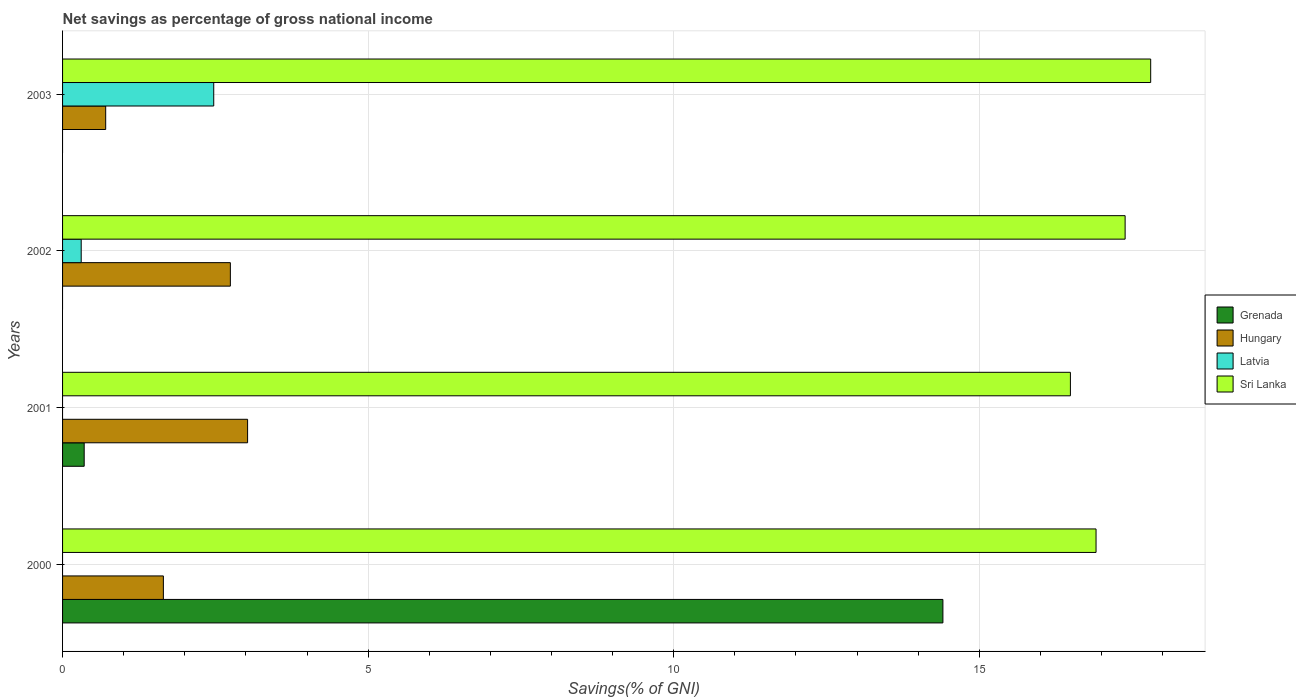How many different coloured bars are there?
Offer a very short reply. 4. How many groups of bars are there?
Offer a very short reply. 4. How many bars are there on the 1st tick from the bottom?
Your response must be concise. 3. What is the label of the 4th group of bars from the top?
Give a very brief answer. 2000. In how many cases, is the number of bars for a given year not equal to the number of legend labels?
Provide a short and direct response. 4. What is the total savings in Latvia in 2000?
Your answer should be compact. 0. Across all years, what is the maximum total savings in Sri Lanka?
Make the answer very short. 17.8. Across all years, what is the minimum total savings in Grenada?
Give a very brief answer. 0. What is the total total savings in Latvia in the graph?
Offer a very short reply. 2.78. What is the difference between the total savings in Hungary in 2001 and that in 2002?
Give a very brief answer. 0.28. What is the difference between the total savings in Grenada in 2001 and the total savings in Latvia in 2003?
Your answer should be compact. -2.12. What is the average total savings in Hungary per year?
Offer a terse response. 2.03. In the year 2003, what is the difference between the total savings in Sri Lanka and total savings in Hungary?
Offer a very short reply. 17.1. In how many years, is the total savings in Grenada greater than 2 %?
Give a very brief answer. 1. What is the ratio of the total savings in Hungary in 2001 to that in 2003?
Offer a terse response. 4.29. Is the total savings in Sri Lanka in 2001 less than that in 2003?
Offer a terse response. Yes. What is the difference between the highest and the second highest total savings in Hungary?
Keep it short and to the point. 0.28. What is the difference between the highest and the lowest total savings in Grenada?
Your answer should be compact. 14.4. Is it the case that in every year, the sum of the total savings in Sri Lanka and total savings in Hungary is greater than the sum of total savings in Latvia and total savings in Grenada?
Your response must be concise. Yes. Is it the case that in every year, the sum of the total savings in Latvia and total savings in Sri Lanka is greater than the total savings in Hungary?
Your response must be concise. Yes. How many bars are there?
Ensure brevity in your answer.  12. Are all the bars in the graph horizontal?
Offer a terse response. Yes. Are the values on the major ticks of X-axis written in scientific E-notation?
Your answer should be compact. No. Does the graph contain any zero values?
Your answer should be compact. Yes. Does the graph contain grids?
Your response must be concise. Yes. How are the legend labels stacked?
Your answer should be compact. Vertical. What is the title of the graph?
Keep it short and to the point. Net savings as percentage of gross national income. Does "Albania" appear as one of the legend labels in the graph?
Your answer should be compact. No. What is the label or title of the X-axis?
Offer a terse response. Savings(% of GNI). What is the label or title of the Y-axis?
Your response must be concise. Years. What is the Savings(% of GNI) of Grenada in 2000?
Keep it short and to the point. 14.4. What is the Savings(% of GNI) in Hungary in 2000?
Provide a short and direct response. 1.65. What is the Savings(% of GNI) of Latvia in 2000?
Keep it short and to the point. 0. What is the Savings(% of GNI) in Sri Lanka in 2000?
Ensure brevity in your answer.  16.91. What is the Savings(% of GNI) in Grenada in 2001?
Offer a very short reply. 0.35. What is the Savings(% of GNI) in Hungary in 2001?
Ensure brevity in your answer.  3.03. What is the Savings(% of GNI) of Latvia in 2001?
Your response must be concise. 0. What is the Savings(% of GNI) of Sri Lanka in 2001?
Provide a succinct answer. 16.49. What is the Savings(% of GNI) of Grenada in 2002?
Keep it short and to the point. 0. What is the Savings(% of GNI) of Hungary in 2002?
Give a very brief answer. 2.75. What is the Savings(% of GNI) in Latvia in 2002?
Your answer should be compact. 0.3. What is the Savings(% of GNI) of Sri Lanka in 2002?
Ensure brevity in your answer.  17.39. What is the Savings(% of GNI) of Grenada in 2003?
Your response must be concise. 0. What is the Savings(% of GNI) of Hungary in 2003?
Give a very brief answer. 0.71. What is the Savings(% of GNI) in Latvia in 2003?
Offer a terse response. 2.47. What is the Savings(% of GNI) in Sri Lanka in 2003?
Offer a very short reply. 17.8. Across all years, what is the maximum Savings(% of GNI) of Grenada?
Your response must be concise. 14.4. Across all years, what is the maximum Savings(% of GNI) of Hungary?
Ensure brevity in your answer.  3.03. Across all years, what is the maximum Savings(% of GNI) of Latvia?
Ensure brevity in your answer.  2.47. Across all years, what is the maximum Savings(% of GNI) in Sri Lanka?
Your answer should be compact. 17.8. Across all years, what is the minimum Savings(% of GNI) in Hungary?
Offer a very short reply. 0.71. Across all years, what is the minimum Savings(% of GNI) in Sri Lanka?
Provide a succinct answer. 16.49. What is the total Savings(% of GNI) of Grenada in the graph?
Ensure brevity in your answer.  14.76. What is the total Savings(% of GNI) in Hungary in the graph?
Make the answer very short. 8.13. What is the total Savings(% of GNI) in Latvia in the graph?
Your response must be concise. 2.78. What is the total Savings(% of GNI) in Sri Lanka in the graph?
Make the answer very short. 68.59. What is the difference between the Savings(% of GNI) in Grenada in 2000 and that in 2001?
Make the answer very short. 14.05. What is the difference between the Savings(% of GNI) of Hungary in 2000 and that in 2001?
Ensure brevity in your answer.  -1.38. What is the difference between the Savings(% of GNI) in Sri Lanka in 2000 and that in 2001?
Keep it short and to the point. 0.42. What is the difference between the Savings(% of GNI) of Hungary in 2000 and that in 2002?
Ensure brevity in your answer.  -1.1. What is the difference between the Savings(% of GNI) of Sri Lanka in 2000 and that in 2002?
Ensure brevity in your answer.  -0.48. What is the difference between the Savings(% of GNI) in Hungary in 2000 and that in 2003?
Give a very brief answer. 0.94. What is the difference between the Savings(% of GNI) of Sri Lanka in 2000 and that in 2003?
Provide a short and direct response. -0.89. What is the difference between the Savings(% of GNI) of Hungary in 2001 and that in 2002?
Your answer should be very brief. 0.28. What is the difference between the Savings(% of GNI) in Sri Lanka in 2001 and that in 2002?
Offer a terse response. -0.9. What is the difference between the Savings(% of GNI) of Hungary in 2001 and that in 2003?
Provide a succinct answer. 2.32. What is the difference between the Savings(% of GNI) in Sri Lanka in 2001 and that in 2003?
Your answer should be very brief. -1.31. What is the difference between the Savings(% of GNI) in Hungary in 2002 and that in 2003?
Your answer should be compact. 2.04. What is the difference between the Savings(% of GNI) of Latvia in 2002 and that in 2003?
Give a very brief answer. -2.17. What is the difference between the Savings(% of GNI) in Sri Lanka in 2002 and that in 2003?
Your answer should be compact. -0.42. What is the difference between the Savings(% of GNI) of Grenada in 2000 and the Savings(% of GNI) of Hungary in 2001?
Your response must be concise. 11.38. What is the difference between the Savings(% of GNI) in Grenada in 2000 and the Savings(% of GNI) in Sri Lanka in 2001?
Ensure brevity in your answer.  -2.09. What is the difference between the Savings(% of GNI) of Hungary in 2000 and the Savings(% of GNI) of Sri Lanka in 2001?
Ensure brevity in your answer.  -14.84. What is the difference between the Savings(% of GNI) in Grenada in 2000 and the Savings(% of GNI) in Hungary in 2002?
Offer a very short reply. 11.66. What is the difference between the Savings(% of GNI) of Grenada in 2000 and the Savings(% of GNI) of Latvia in 2002?
Give a very brief answer. 14.1. What is the difference between the Savings(% of GNI) of Grenada in 2000 and the Savings(% of GNI) of Sri Lanka in 2002?
Give a very brief answer. -2.98. What is the difference between the Savings(% of GNI) in Hungary in 2000 and the Savings(% of GNI) in Latvia in 2002?
Your answer should be very brief. 1.34. What is the difference between the Savings(% of GNI) of Hungary in 2000 and the Savings(% of GNI) of Sri Lanka in 2002?
Keep it short and to the point. -15.74. What is the difference between the Savings(% of GNI) of Grenada in 2000 and the Savings(% of GNI) of Hungary in 2003?
Your response must be concise. 13.7. What is the difference between the Savings(% of GNI) in Grenada in 2000 and the Savings(% of GNI) in Latvia in 2003?
Your response must be concise. 11.93. What is the difference between the Savings(% of GNI) of Grenada in 2000 and the Savings(% of GNI) of Sri Lanka in 2003?
Offer a terse response. -3.4. What is the difference between the Savings(% of GNI) in Hungary in 2000 and the Savings(% of GNI) in Latvia in 2003?
Give a very brief answer. -0.82. What is the difference between the Savings(% of GNI) in Hungary in 2000 and the Savings(% of GNI) in Sri Lanka in 2003?
Give a very brief answer. -16.16. What is the difference between the Savings(% of GNI) of Grenada in 2001 and the Savings(% of GNI) of Hungary in 2002?
Ensure brevity in your answer.  -2.39. What is the difference between the Savings(% of GNI) in Grenada in 2001 and the Savings(% of GNI) in Latvia in 2002?
Keep it short and to the point. 0.05. What is the difference between the Savings(% of GNI) of Grenada in 2001 and the Savings(% of GNI) of Sri Lanka in 2002?
Keep it short and to the point. -17.03. What is the difference between the Savings(% of GNI) of Hungary in 2001 and the Savings(% of GNI) of Latvia in 2002?
Provide a succinct answer. 2.72. What is the difference between the Savings(% of GNI) of Hungary in 2001 and the Savings(% of GNI) of Sri Lanka in 2002?
Your response must be concise. -14.36. What is the difference between the Savings(% of GNI) of Grenada in 2001 and the Savings(% of GNI) of Hungary in 2003?
Offer a very short reply. -0.35. What is the difference between the Savings(% of GNI) in Grenada in 2001 and the Savings(% of GNI) in Latvia in 2003?
Provide a short and direct response. -2.12. What is the difference between the Savings(% of GNI) of Grenada in 2001 and the Savings(% of GNI) of Sri Lanka in 2003?
Your answer should be very brief. -17.45. What is the difference between the Savings(% of GNI) of Hungary in 2001 and the Savings(% of GNI) of Latvia in 2003?
Offer a very short reply. 0.55. What is the difference between the Savings(% of GNI) of Hungary in 2001 and the Savings(% of GNI) of Sri Lanka in 2003?
Give a very brief answer. -14.78. What is the difference between the Savings(% of GNI) in Hungary in 2002 and the Savings(% of GNI) in Latvia in 2003?
Give a very brief answer. 0.27. What is the difference between the Savings(% of GNI) of Hungary in 2002 and the Savings(% of GNI) of Sri Lanka in 2003?
Your response must be concise. -15.06. What is the difference between the Savings(% of GNI) in Latvia in 2002 and the Savings(% of GNI) in Sri Lanka in 2003?
Offer a terse response. -17.5. What is the average Savings(% of GNI) of Grenada per year?
Offer a terse response. 3.69. What is the average Savings(% of GNI) of Hungary per year?
Make the answer very short. 2.03. What is the average Savings(% of GNI) in Latvia per year?
Your answer should be compact. 0.69. What is the average Savings(% of GNI) in Sri Lanka per year?
Your answer should be compact. 17.15. In the year 2000, what is the difference between the Savings(% of GNI) of Grenada and Savings(% of GNI) of Hungary?
Give a very brief answer. 12.76. In the year 2000, what is the difference between the Savings(% of GNI) of Grenada and Savings(% of GNI) of Sri Lanka?
Offer a terse response. -2.51. In the year 2000, what is the difference between the Savings(% of GNI) of Hungary and Savings(% of GNI) of Sri Lanka?
Provide a short and direct response. -15.26. In the year 2001, what is the difference between the Savings(% of GNI) of Grenada and Savings(% of GNI) of Hungary?
Provide a short and direct response. -2.67. In the year 2001, what is the difference between the Savings(% of GNI) of Grenada and Savings(% of GNI) of Sri Lanka?
Your answer should be compact. -16.14. In the year 2001, what is the difference between the Savings(% of GNI) in Hungary and Savings(% of GNI) in Sri Lanka?
Your answer should be compact. -13.46. In the year 2002, what is the difference between the Savings(% of GNI) of Hungary and Savings(% of GNI) of Latvia?
Keep it short and to the point. 2.44. In the year 2002, what is the difference between the Savings(% of GNI) of Hungary and Savings(% of GNI) of Sri Lanka?
Your answer should be compact. -14.64. In the year 2002, what is the difference between the Savings(% of GNI) in Latvia and Savings(% of GNI) in Sri Lanka?
Your response must be concise. -17.08. In the year 2003, what is the difference between the Savings(% of GNI) in Hungary and Savings(% of GNI) in Latvia?
Provide a short and direct response. -1.77. In the year 2003, what is the difference between the Savings(% of GNI) of Hungary and Savings(% of GNI) of Sri Lanka?
Offer a terse response. -17.1. In the year 2003, what is the difference between the Savings(% of GNI) in Latvia and Savings(% of GNI) in Sri Lanka?
Provide a succinct answer. -15.33. What is the ratio of the Savings(% of GNI) in Grenada in 2000 to that in 2001?
Your answer should be compact. 40.71. What is the ratio of the Savings(% of GNI) in Hungary in 2000 to that in 2001?
Ensure brevity in your answer.  0.54. What is the ratio of the Savings(% of GNI) of Sri Lanka in 2000 to that in 2001?
Ensure brevity in your answer.  1.03. What is the ratio of the Savings(% of GNI) in Hungary in 2000 to that in 2002?
Provide a succinct answer. 0.6. What is the ratio of the Savings(% of GNI) of Sri Lanka in 2000 to that in 2002?
Your answer should be compact. 0.97. What is the ratio of the Savings(% of GNI) in Hungary in 2000 to that in 2003?
Give a very brief answer. 2.34. What is the ratio of the Savings(% of GNI) of Sri Lanka in 2000 to that in 2003?
Your answer should be compact. 0.95. What is the ratio of the Savings(% of GNI) of Hungary in 2001 to that in 2002?
Your response must be concise. 1.1. What is the ratio of the Savings(% of GNI) of Sri Lanka in 2001 to that in 2002?
Provide a short and direct response. 0.95. What is the ratio of the Savings(% of GNI) of Hungary in 2001 to that in 2003?
Offer a terse response. 4.29. What is the ratio of the Savings(% of GNI) in Sri Lanka in 2001 to that in 2003?
Keep it short and to the point. 0.93. What is the ratio of the Savings(% of GNI) in Hungary in 2002 to that in 2003?
Your answer should be very brief. 3.89. What is the ratio of the Savings(% of GNI) in Latvia in 2002 to that in 2003?
Offer a very short reply. 0.12. What is the ratio of the Savings(% of GNI) in Sri Lanka in 2002 to that in 2003?
Your response must be concise. 0.98. What is the difference between the highest and the second highest Savings(% of GNI) of Hungary?
Make the answer very short. 0.28. What is the difference between the highest and the second highest Savings(% of GNI) in Sri Lanka?
Keep it short and to the point. 0.42. What is the difference between the highest and the lowest Savings(% of GNI) in Grenada?
Ensure brevity in your answer.  14.4. What is the difference between the highest and the lowest Savings(% of GNI) of Hungary?
Provide a short and direct response. 2.32. What is the difference between the highest and the lowest Savings(% of GNI) in Latvia?
Offer a terse response. 2.47. What is the difference between the highest and the lowest Savings(% of GNI) in Sri Lanka?
Make the answer very short. 1.31. 